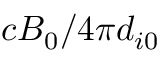<formula> <loc_0><loc_0><loc_500><loc_500>c B _ { 0 } / 4 \pi d _ { i 0 }</formula> 